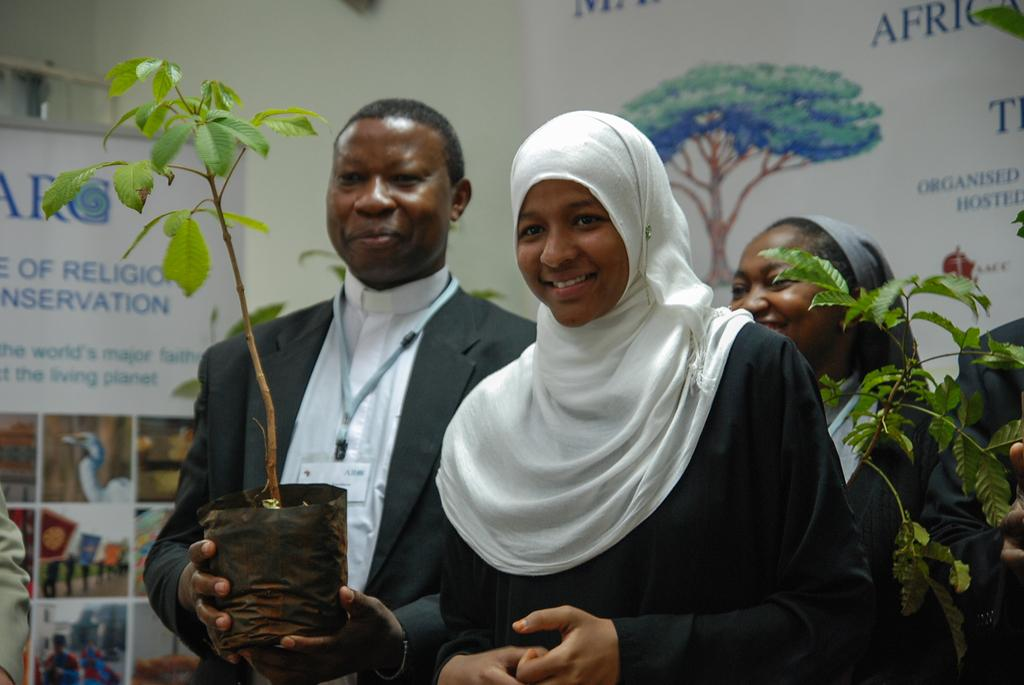What can be seen in the foreground of the image? There are people standing in the foreground of the image. What are some of the people holding? Some of the people are holding plant pots. What is visible in the background of the image? There are posters in the background of the image. Can you see a man carrying a basket in the image? There is no man carrying a basket in the image. Is there a giraffe visible in the image? There is no giraffe present in the image. 